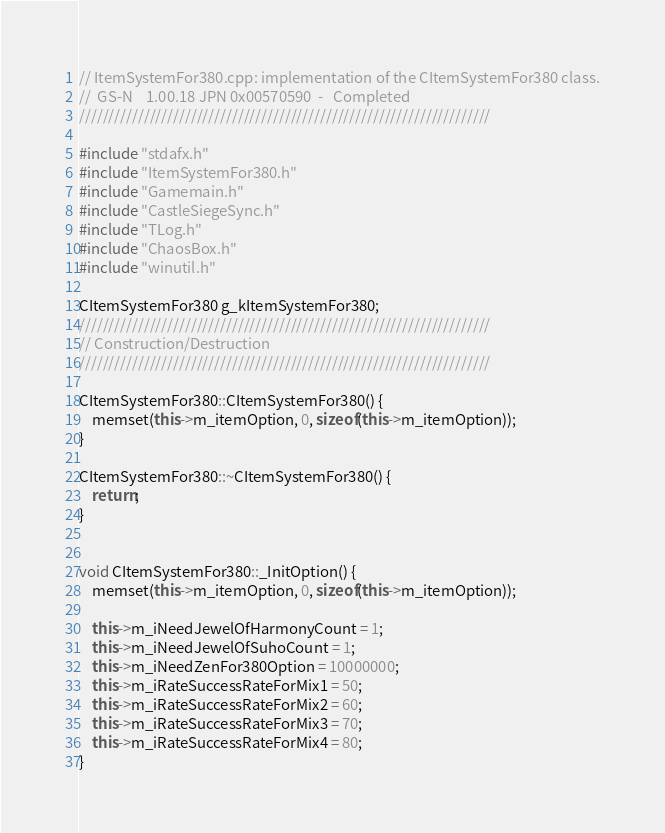<code> <loc_0><loc_0><loc_500><loc_500><_C++_>// ItemSystemFor380.cpp: implementation of the CItemSystemFor380 class.
//	GS-N	1.00.18	JPN	0x00570590	-	Completed
//////////////////////////////////////////////////////////////////////

#include "stdafx.h"
#include "ItemSystemFor380.h"
#include "Gamemain.h"
#include "CastleSiegeSync.h"
#include "TLog.h"
#include "ChaosBox.h"
#include "winutil.h"

CItemSystemFor380 g_kItemSystemFor380;
//////////////////////////////////////////////////////////////////////
// Construction/Destruction
//////////////////////////////////////////////////////////////////////

CItemSystemFor380::CItemSystemFor380() {
    memset(this->m_itemOption, 0, sizeof(this->m_itemOption));
}

CItemSystemFor380::~CItemSystemFor380() {
    return;
}


void CItemSystemFor380::_InitOption() {
    memset(this->m_itemOption, 0, sizeof(this->m_itemOption));

    this->m_iNeedJewelOfHarmonyCount = 1;
    this->m_iNeedJewelOfSuhoCount = 1;
    this->m_iNeedZenFor380Option = 10000000;
    this->m_iRateSuccessRateForMix1 = 50;
    this->m_iRateSuccessRateForMix2 = 60;
    this->m_iRateSuccessRateForMix3 = 70;
    this->m_iRateSuccessRateForMix4 = 80;
}

</code> 